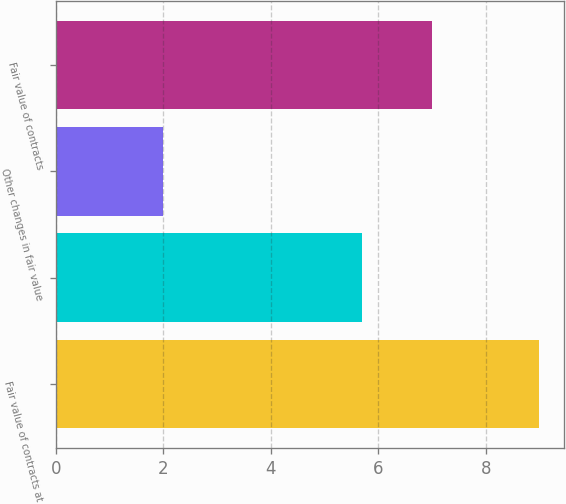Convert chart. <chart><loc_0><loc_0><loc_500><loc_500><bar_chart><fcel>Fair value of contracts at<fcel>Unnamed: 1<fcel>Other changes in fair value<fcel>Fair value of contracts<nl><fcel>9<fcel>5.7<fcel>2<fcel>7<nl></chart> 